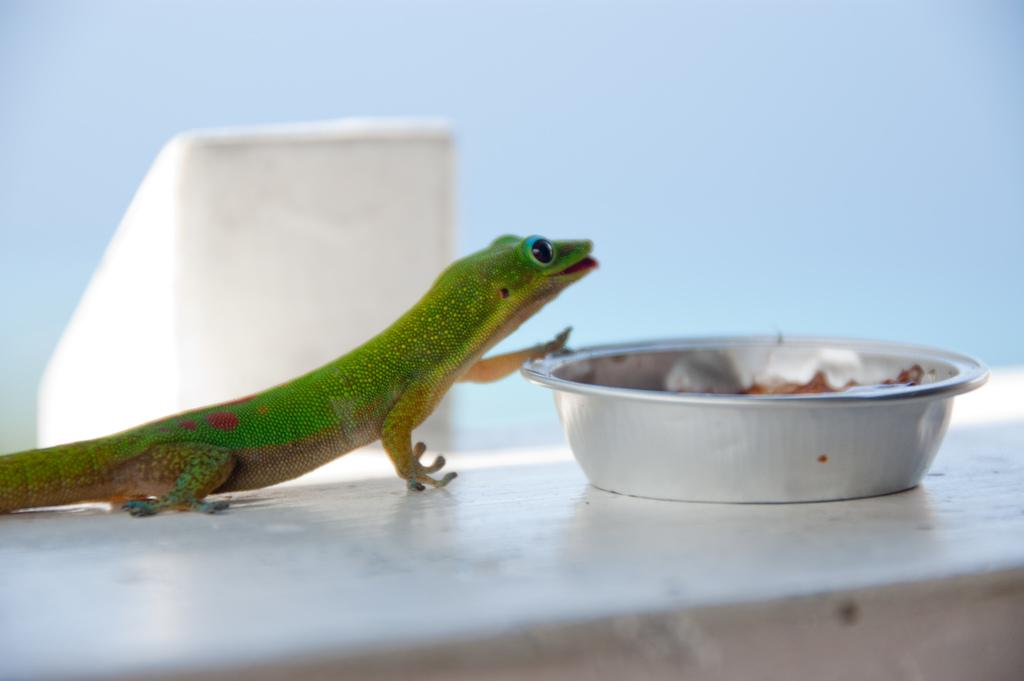What type of animal is in the image? There is a Green anole in the image. What object is also present in the image? There is a bowl in the image. What flavor of cast can be seen on the Green anole's leg in the image? There is no cast present on the Green anole's leg in the image, nor is there any mention of a cast or its flavor. 